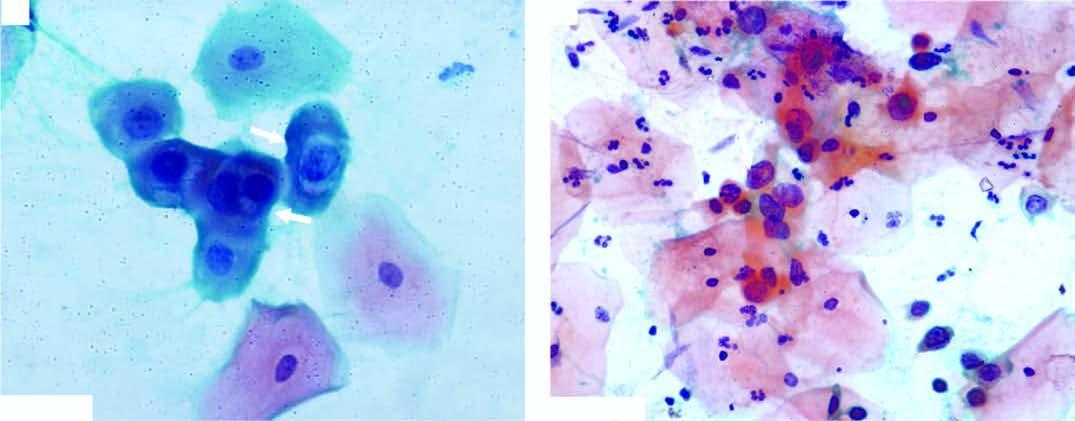what shows koilocytes having abundant vacuolated cytoplasm and nuclear enlargement?
Answer the question using a single word or phrase. Smear 